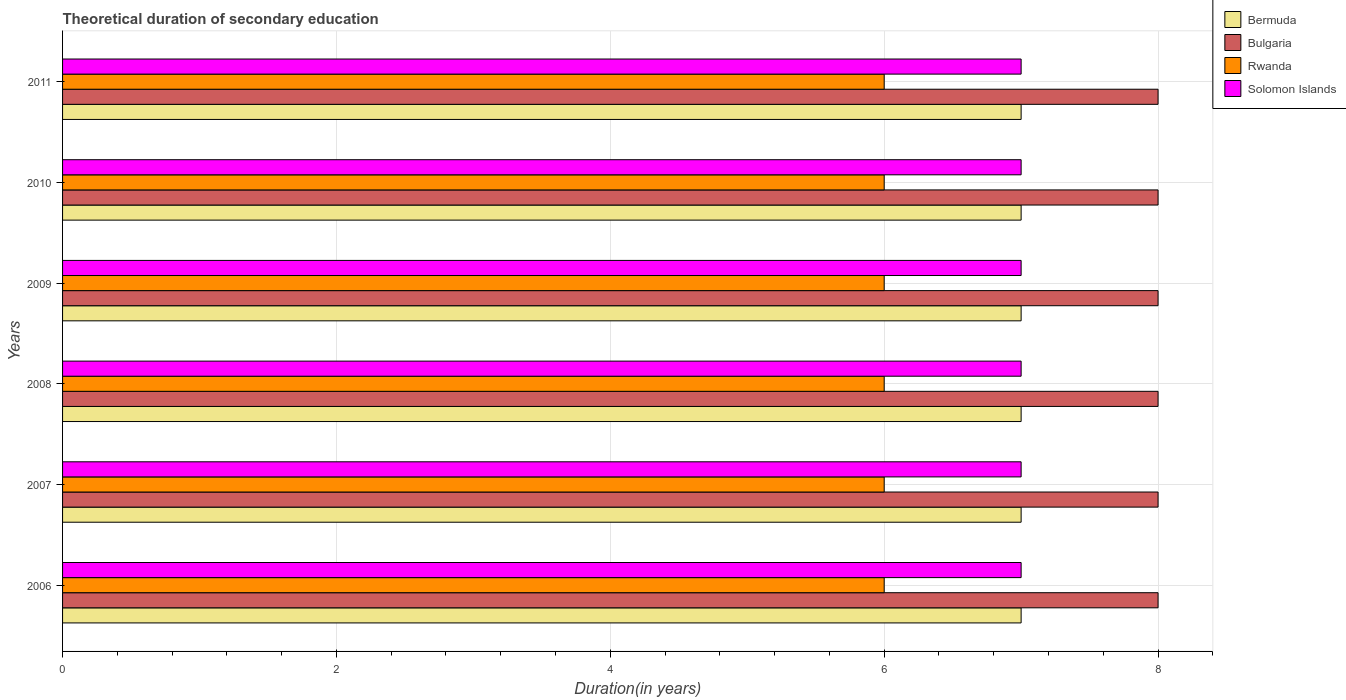How many different coloured bars are there?
Provide a short and direct response. 4. How many groups of bars are there?
Provide a short and direct response. 6. Are the number of bars on each tick of the Y-axis equal?
Keep it short and to the point. Yes. How many bars are there on the 6th tick from the top?
Your answer should be compact. 4. What is the total theoretical duration of secondary education in Bermuda in 2008?
Provide a short and direct response. 7. Across all years, what is the maximum total theoretical duration of secondary education in Solomon Islands?
Keep it short and to the point. 7. Across all years, what is the minimum total theoretical duration of secondary education in Bermuda?
Your response must be concise. 7. In which year was the total theoretical duration of secondary education in Bulgaria minimum?
Your response must be concise. 2006. What is the total total theoretical duration of secondary education in Solomon Islands in the graph?
Offer a very short reply. 42. What is the difference between the total theoretical duration of secondary education in Bermuda in 2007 and that in 2010?
Provide a succinct answer. 0. What is the difference between the total theoretical duration of secondary education in Solomon Islands in 2009 and the total theoretical duration of secondary education in Rwanda in 2007?
Offer a terse response. 1. In the year 2006, what is the difference between the total theoretical duration of secondary education in Rwanda and total theoretical duration of secondary education in Solomon Islands?
Make the answer very short. -1. In how many years, is the total theoretical duration of secondary education in Bermuda greater than 4.4 years?
Keep it short and to the point. 6. What is the ratio of the total theoretical duration of secondary education in Solomon Islands in 2010 to that in 2011?
Keep it short and to the point. 1. What is the difference between the highest and the second highest total theoretical duration of secondary education in Bermuda?
Ensure brevity in your answer.  0. In how many years, is the total theoretical duration of secondary education in Bulgaria greater than the average total theoretical duration of secondary education in Bulgaria taken over all years?
Your answer should be very brief. 0. What does the 1st bar from the top in 2011 represents?
Your answer should be compact. Solomon Islands. What does the 4th bar from the bottom in 2007 represents?
Your answer should be very brief. Solomon Islands. What is the difference between two consecutive major ticks on the X-axis?
Provide a short and direct response. 2. Are the values on the major ticks of X-axis written in scientific E-notation?
Your response must be concise. No. How many legend labels are there?
Provide a short and direct response. 4. What is the title of the graph?
Provide a short and direct response. Theoretical duration of secondary education. Does "Swaziland" appear as one of the legend labels in the graph?
Provide a succinct answer. No. What is the label or title of the X-axis?
Ensure brevity in your answer.  Duration(in years). What is the Duration(in years) in Bulgaria in 2006?
Offer a very short reply. 8. What is the Duration(in years) in Rwanda in 2006?
Your answer should be compact. 6. What is the Duration(in years) of Bulgaria in 2007?
Your response must be concise. 8. What is the Duration(in years) of Rwanda in 2007?
Your answer should be very brief. 6. What is the Duration(in years) of Bulgaria in 2008?
Make the answer very short. 8. What is the Duration(in years) of Solomon Islands in 2008?
Make the answer very short. 7. What is the Duration(in years) of Bulgaria in 2009?
Offer a very short reply. 8. What is the Duration(in years) in Rwanda in 2009?
Your answer should be compact. 6. What is the Duration(in years) in Solomon Islands in 2009?
Your answer should be compact. 7. What is the Duration(in years) in Bermuda in 2010?
Keep it short and to the point. 7. What is the Duration(in years) of Bulgaria in 2010?
Ensure brevity in your answer.  8. What is the Duration(in years) of Bermuda in 2011?
Offer a very short reply. 7. What is the Duration(in years) of Solomon Islands in 2011?
Offer a very short reply. 7. Across all years, what is the maximum Duration(in years) in Bermuda?
Offer a very short reply. 7. Across all years, what is the maximum Duration(in years) in Bulgaria?
Offer a very short reply. 8. Across all years, what is the maximum Duration(in years) in Rwanda?
Keep it short and to the point. 6. Across all years, what is the maximum Duration(in years) in Solomon Islands?
Provide a short and direct response. 7. Across all years, what is the minimum Duration(in years) in Rwanda?
Provide a short and direct response. 6. Across all years, what is the minimum Duration(in years) of Solomon Islands?
Your answer should be compact. 7. What is the total Duration(in years) of Bermuda in the graph?
Provide a short and direct response. 42. What is the total Duration(in years) of Bulgaria in the graph?
Keep it short and to the point. 48. What is the total Duration(in years) in Rwanda in the graph?
Give a very brief answer. 36. What is the difference between the Duration(in years) of Bermuda in 2006 and that in 2007?
Give a very brief answer. 0. What is the difference between the Duration(in years) in Bulgaria in 2006 and that in 2007?
Provide a succinct answer. 0. What is the difference between the Duration(in years) of Rwanda in 2006 and that in 2007?
Keep it short and to the point. 0. What is the difference between the Duration(in years) of Bulgaria in 2006 and that in 2008?
Keep it short and to the point. 0. What is the difference between the Duration(in years) in Solomon Islands in 2006 and that in 2008?
Offer a very short reply. 0. What is the difference between the Duration(in years) in Bulgaria in 2006 and that in 2009?
Keep it short and to the point. 0. What is the difference between the Duration(in years) in Solomon Islands in 2006 and that in 2009?
Offer a very short reply. 0. What is the difference between the Duration(in years) of Solomon Islands in 2006 and that in 2010?
Offer a very short reply. 0. What is the difference between the Duration(in years) in Bulgaria in 2006 and that in 2011?
Make the answer very short. 0. What is the difference between the Duration(in years) in Solomon Islands in 2006 and that in 2011?
Provide a succinct answer. 0. What is the difference between the Duration(in years) of Bulgaria in 2007 and that in 2008?
Provide a short and direct response. 0. What is the difference between the Duration(in years) of Bermuda in 2007 and that in 2009?
Your answer should be compact. 0. What is the difference between the Duration(in years) in Solomon Islands in 2007 and that in 2009?
Your answer should be compact. 0. What is the difference between the Duration(in years) in Bulgaria in 2007 and that in 2010?
Your response must be concise. 0. What is the difference between the Duration(in years) in Rwanda in 2007 and that in 2010?
Offer a very short reply. 0. What is the difference between the Duration(in years) in Solomon Islands in 2007 and that in 2010?
Keep it short and to the point. 0. What is the difference between the Duration(in years) of Bermuda in 2007 and that in 2011?
Your response must be concise. 0. What is the difference between the Duration(in years) in Solomon Islands in 2007 and that in 2011?
Provide a short and direct response. 0. What is the difference between the Duration(in years) of Bermuda in 2008 and that in 2009?
Provide a short and direct response. 0. What is the difference between the Duration(in years) in Bulgaria in 2008 and that in 2009?
Your response must be concise. 0. What is the difference between the Duration(in years) of Bulgaria in 2008 and that in 2010?
Provide a succinct answer. 0. What is the difference between the Duration(in years) of Rwanda in 2008 and that in 2010?
Provide a succinct answer. 0. What is the difference between the Duration(in years) in Solomon Islands in 2008 and that in 2010?
Provide a short and direct response. 0. What is the difference between the Duration(in years) of Bermuda in 2008 and that in 2011?
Make the answer very short. 0. What is the difference between the Duration(in years) in Rwanda in 2008 and that in 2011?
Your response must be concise. 0. What is the difference between the Duration(in years) in Bermuda in 2009 and that in 2010?
Ensure brevity in your answer.  0. What is the difference between the Duration(in years) in Solomon Islands in 2009 and that in 2010?
Keep it short and to the point. 0. What is the difference between the Duration(in years) in Bermuda in 2009 and that in 2011?
Your response must be concise. 0. What is the difference between the Duration(in years) of Rwanda in 2009 and that in 2011?
Your answer should be compact. 0. What is the difference between the Duration(in years) of Bulgaria in 2010 and that in 2011?
Your answer should be very brief. 0. What is the difference between the Duration(in years) in Bermuda in 2006 and the Duration(in years) in Rwanda in 2007?
Keep it short and to the point. 1. What is the difference between the Duration(in years) in Bulgaria in 2006 and the Duration(in years) in Rwanda in 2007?
Provide a short and direct response. 2. What is the difference between the Duration(in years) in Bulgaria in 2006 and the Duration(in years) in Solomon Islands in 2007?
Provide a succinct answer. 1. What is the difference between the Duration(in years) of Rwanda in 2006 and the Duration(in years) of Solomon Islands in 2007?
Your answer should be very brief. -1. What is the difference between the Duration(in years) of Bermuda in 2006 and the Duration(in years) of Bulgaria in 2008?
Your answer should be compact. -1. What is the difference between the Duration(in years) of Bermuda in 2006 and the Duration(in years) of Solomon Islands in 2008?
Give a very brief answer. 0. What is the difference between the Duration(in years) in Rwanda in 2006 and the Duration(in years) in Solomon Islands in 2008?
Make the answer very short. -1. What is the difference between the Duration(in years) of Bermuda in 2006 and the Duration(in years) of Rwanda in 2009?
Provide a succinct answer. 1. What is the difference between the Duration(in years) of Bermuda in 2006 and the Duration(in years) of Solomon Islands in 2009?
Provide a succinct answer. 0. What is the difference between the Duration(in years) of Bulgaria in 2006 and the Duration(in years) of Rwanda in 2009?
Keep it short and to the point. 2. What is the difference between the Duration(in years) of Bulgaria in 2006 and the Duration(in years) of Solomon Islands in 2009?
Offer a very short reply. 1. What is the difference between the Duration(in years) of Bermuda in 2006 and the Duration(in years) of Rwanda in 2010?
Your answer should be compact. 1. What is the difference between the Duration(in years) of Bermuda in 2006 and the Duration(in years) of Solomon Islands in 2010?
Ensure brevity in your answer.  0. What is the difference between the Duration(in years) in Rwanda in 2006 and the Duration(in years) in Solomon Islands in 2010?
Make the answer very short. -1. What is the difference between the Duration(in years) in Bermuda in 2006 and the Duration(in years) in Bulgaria in 2011?
Offer a very short reply. -1. What is the difference between the Duration(in years) of Bermuda in 2006 and the Duration(in years) of Rwanda in 2011?
Provide a succinct answer. 1. What is the difference between the Duration(in years) of Bulgaria in 2006 and the Duration(in years) of Solomon Islands in 2011?
Offer a terse response. 1. What is the difference between the Duration(in years) of Bermuda in 2007 and the Duration(in years) of Bulgaria in 2008?
Provide a succinct answer. -1. What is the difference between the Duration(in years) in Bermuda in 2007 and the Duration(in years) in Rwanda in 2008?
Your response must be concise. 1. What is the difference between the Duration(in years) in Bermuda in 2007 and the Duration(in years) in Solomon Islands in 2008?
Ensure brevity in your answer.  0. What is the difference between the Duration(in years) in Bulgaria in 2007 and the Duration(in years) in Rwanda in 2008?
Offer a very short reply. 2. What is the difference between the Duration(in years) of Rwanda in 2007 and the Duration(in years) of Solomon Islands in 2008?
Your answer should be very brief. -1. What is the difference between the Duration(in years) of Bermuda in 2007 and the Duration(in years) of Solomon Islands in 2009?
Ensure brevity in your answer.  0. What is the difference between the Duration(in years) of Bermuda in 2007 and the Duration(in years) of Rwanda in 2010?
Offer a very short reply. 1. What is the difference between the Duration(in years) of Bermuda in 2007 and the Duration(in years) of Solomon Islands in 2010?
Make the answer very short. 0. What is the difference between the Duration(in years) of Rwanda in 2007 and the Duration(in years) of Solomon Islands in 2010?
Provide a short and direct response. -1. What is the difference between the Duration(in years) of Rwanda in 2007 and the Duration(in years) of Solomon Islands in 2011?
Your answer should be compact. -1. What is the difference between the Duration(in years) of Bermuda in 2008 and the Duration(in years) of Rwanda in 2009?
Provide a short and direct response. 1. What is the difference between the Duration(in years) in Bulgaria in 2008 and the Duration(in years) in Rwanda in 2009?
Offer a terse response. 2. What is the difference between the Duration(in years) in Bulgaria in 2008 and the Duration(in years) in Solomon Islands in 2009?
Keep it short and to the point. 1. What is the difference between the Duration(in years) of Rwanda in 2008 and the Duration(in years) of Solomon Islands in 2009?
Keep it short and to the point. -1. What is the difference between the Duration(in years) of Bermuda in 2008 and the Duration(in years) of Bulgaria in 2010?
Your answer should be very brief. -1. What is the difference between the Duration(in years) of Bulgaria in 2008 and the Duration(in years) of Solomon Islands in 2010?
Provide a short and direct response. 1. What is the difference between the Duration(in years) in Rwanda in 2008 and the Duration(in years) in Solomon Islands in 2010?
Ensure brevity in your answer.  -1. What is the difference between the Duration(in years) in Bermuda in 2008 and the Duration(in years) in Rwanda in 2011?
Keep it short and to the point. 1. What is the difference between the Duration(in years) in Bermuda in 2008 and the Duration(in years) in Solomon Islands in 2011?
Offer a terse response. 0. What is the difference between the Duration(in years) of Bulgaria in 2008 and the Duration(in years) of Rwanda in 2011?
Your answer should be compact. 2. What is the difference between the Duration(in years) of Rwanda in 2008 and the Duration(in years) of Solomon Islands in 2011?
Make the answer very short. -1. What is the difference between the Duration(in years) in Bermuda in 2009 and the Duration(in years) in Bulgaria in 2010?
Keep it short and to the point. -1. What is the difference between the Duration(in years) in Bermuda in 2009 and the Duration(in years) in Rwanda in 2010?
Offer a very short reply. 1. What is the difference between the Duration(in years) in Bermuda in 2009 and the Duration(in years) in Solomon Islands in 2010?
Your answer should be very brief. 0. What is the difference between the Duration(in years) of Bulgaria in 2009 and the Duration(in years) of Rwanda in 2010?
Keep it short and to the point. 2. What is the difference between the Duration(in years) in Bulgaria in 2009 and the Duration(in years) in Solomon Islands in 2010?
Offer a terse response. 1. What is the difference between the Duration(in years) in Rwanda in 2009 and the Duration(in years) in Solomon Islands in 2010?
Your answer should be compact. -1. What is the difference between the Duration(in years) of Bulgaria in 2009 and the Duration(in years) of Solomon Islands in 2011?
Give a very brief answer. 1. What is the difference between the Duration(in years) of Bermuda in 2010 and the Duration(in years) of Bulgaria in 2011?
Your answer should be compact. -1. What is the difference between the Duration(in years) of Bermuda in 2010 and the Duration(in years) of Rwanda in 2011?
Your answer should be compact. 1. What is the difference between the Duration(in years) in Bulgaria in 2010 and the Duration(in years) in Rwanda in 2011?
Your answer should be compact. 2. What is the average Duration(in years) in Bermuda per year?
Your response must be concise. 7. What is the average Duration(in years) in Solomon Islands per year?
Make the answer very short. 7. In the year 2006, what is the difference between the Duration(in years) of Bermuda and Duration(in years) of Rwanda?
Offer a very short reply. 1. In the year 2006, what is the difference between the Duration(in years) in Bermuda and Duration(in years) in Solomon Islands?
Your answer should be compact. 0. In the year 2006, what is the difference between the Duration(in years) in Bulgaria and Duration(in years) in Rwanda?
Make the answer very short. 2. In the year 2006, what is the difference between the Duration(in years) in Bulgaria and Duration(in years) in Solomon Islands?
Offer a terse response. 1. In the year 2007, what is the difference between the Duration(in years) in Bermuda and Duration(in years) in Bulgaria?
Provide a short and direct response. -1. In the year 2007, what is the difference between the Duration(in years) of Bermuda and Duration(in years) of Solomon Islands?
Ensure brevity in your answer.  0. In the year 2008, what is the difference between the Duration(in years) in Bermuda and Duration(in years) in Rwanda?
Offer a very short reply. 1. In the year 2009, what is the difference between the Duration(in years) in Bermuda and Duration(in years) in Bulgaria?
Offer a terse response. -1. In the year 2009, what is the difference between the Duration(in years) of Bermuda and Duration(in years) of Rwanda?
Give a very brief answer. 1. In the year 2009, what is the difference between the Duration(in years) in Bulgaria and Duration(in years) in Rwanda?
Your answer should be compact. 2. In the year 2009, what is the difference between the Duration(in years) in Bulgaria and Duration(in years) in Solomon Islands?
Provide a short and direct response. 1. In the year 2010, what is the difference between the Duration(in years) of Bermuda and Duration(in years) of Bulgaria?
Provide a succinct answer. -1. In the year 2010, what is the difference between the Duration(in years) of Bermuda and Duration(in years) of Rwanda?
Give a very brief answer. 1. In the year 2010, what is the difference between the Duration(in years) in Bermuda and Duration(in years) in Solomon Islands?
Keep it short and to the point. 0. In the year 2010, what is the difference between the Duration(in years) in Bulgaria and Duration(in years) in Rwanda?
Provide a short and direct response. 2. In the year 2010, what is the difference between the Duration(in years) of Bulgaria and Duration(in years) of Solomon Islands?
Offer a very short reply. 1. In the year 2011, what is the difference between the Duration(in years) in Bermuda and Duration(in years) in Bulgaria?
Provide a succinct answer. -1. In the year 2011, what is the difference between the Duration(in years) in Bulgaria and Duration(in years) in Solomon Islands?
Give a very brief answer. 1. What is the ratio of the Duration(in years) of Rwanda in 2006 to that in 2007?
Ensure brevity in your answer.  1. What is the ratio of the Duration(in years) in Bulgaria in 2006 to that in 2008?
Your answer should be compact. 1. What is the ratio of the Duration(in years) in Solomon Islands in 2006 to that in 2008?
Provide a short and direct response. 1. What is the ratio of the Duration(in years) in Rwanda in 2006 to that in 2009?
Your answer should be compact. 1. What is the ratio of the Duration(in years) in Rwanda in 2006 to that in 2010?
Give a very brief answer. 1. What is the ratio of the Duration(in years) of Bermuda in 2006 to that in 2011?
Your answer should be compact. 1. What is the ratio of the Duration(in years) of Rwanda in 2007 to that in 2008?
Offer a very short reply. 1. What is the ratio of the Duration(in years) of Bulgaria in 2007 to that in 2009?
Offer a terse response. 1. What is the ratio of the Duration(in years) of Rwanda in 2007 to that in 2009?
Make the answer very short. 1. What is the ratio of the Duration(in years) of Solomon Islands in 2007 to that in 2009?
Your answer should be very brief. 1. What is the ratio of the Duration(in years) in Solomon Islands in 2007 to that in 2010?
Your response must be concise. 1. What is the ratio of the Duration(in years) of Bulgaria in 2007 to that in 2011?
Ensure brevity in your answer.  1. What is the ratio of the Duration(in years) in Rwanda in 2008 to that in 2009?
Keep it short and to the point. 1. What is the ratio of the Duration(in years) of Solomon Islands in 2008 to that in 2009?
Make the answer very short. 1. What is the ratio of the Duration(in years) of Solomon Islands in 2008 to that in 2011?
Make the answer very short. 1. What is the ratio of the Duration(in years) in Bulgaria in 2009 to that in 2010?
Give a very brief answer. 1. What is the ratio of the Duration(in years) of Bermuda in 2009 to that in 2011?
Give a very brief answer. 1. What is the ratio of the Duration(in years) of Bulgaria in 2009 to that in 2011?
Your response must be concise. 1. What is the ratio of the Duration(in years) of Rwanda in 2009 to that in 2011?
Ensure brevity in your answer.  1. What is the ratio of the Duration(in years) of Solomon Islands in 2009 to that in 2011?
Make the answer very short. 1. What is the ratio of the Duration(in years) of Bulgaria in 2010 to that in 2011?
Give a very brief answer. 1. What is the ratio of the Duration(in years) of Solomon Islands in 2010 to that in 2011?
Make the answer very short. 1. What is the difference between the highest and the second highest Duration(in years) in Bermuda?
Keep it short and to the point. 0. What is the difference between the highest and the second highest Duration(in years) of Solomon Islands?
Provide a short and direct response. 0. What is the difference between the highest and the lowest Duration(in years) of Bermuda?
Ensure brevity in your answer.  0. What is the difference between the highest and the lowest Duration(in years) of Rwanda?
Your response must be concise. 0. What is the difference between the highest and the lowest Duration(in years) of Solomon Islands?
Keep it short and to the point. 0. 